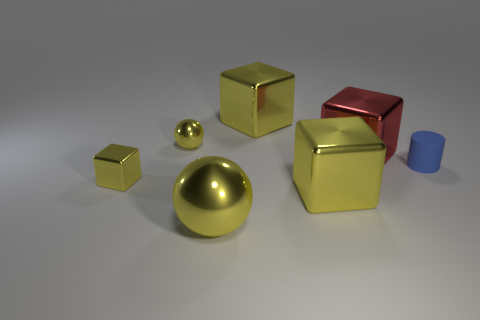Is there any other thing of the same color as the small metal block?
Your response must be concise. Yes. What size is the other ball that is the same material as the big sphere?
Make the answer very short. Small. Is the red object made of the same material as the big block in front of the tiny matte object?
Provide a succinct answer. Yes. Are there more objects in front of the small rubber thing than large yellow metallic spheres?
Keep it short and to the point. Yes. There is a tiny thing that is the same color as the small metallic ball; what is its shape?
Ensure brevity in your answer.  Cube. Is there a blue block that has the same material as the blue object?
Your answer should be compact. No. Do the large cube that is in front of the small rubber cylinder and the ball behind the large metallic ball have the same material?
Provide a short and direct response. Yes. Are there the same number of red objects that are left of the red metal object and large objects behind the blue object?
Keep it short and to the point. No. There is a ball that is the same size as the blue rubber object; what color is it?
Ensure brevity in your answer.  Yellow. Is there a large thing that has the same color as the small metal ball?
Offer a terse response. Yes. 